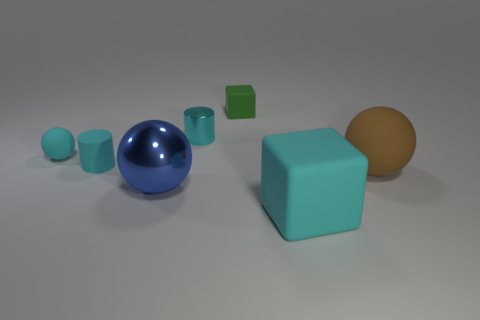Subtract 1 spheres. How many spheres are left? 2 Subtract all tiny matte balls. How many balls are left? 2 Add 1 big blue things. How many objects exist? 8 Subtract all balls. How many objects are left? 4 Subtract all cyan balls. How many balls are left? 2 Subtract all red balls. Subtract all gray cylinders. How many balls are left? 3 Subtract all cyan cylinders. How many blue balls are left? 1 Subtract all tiny shiny cubes. Subtract all large brown rubber objects. How many objects are left? 6 Add 1 large brown rubber balls. How many large brown rubber balls are left? 2 Add 6 large brown matte spheres. How many large brown matte spheres exist? 7 